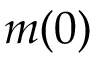<formula> <loc_0><loc_0><loc_500><loc_500>m ( 0 )</formula> 